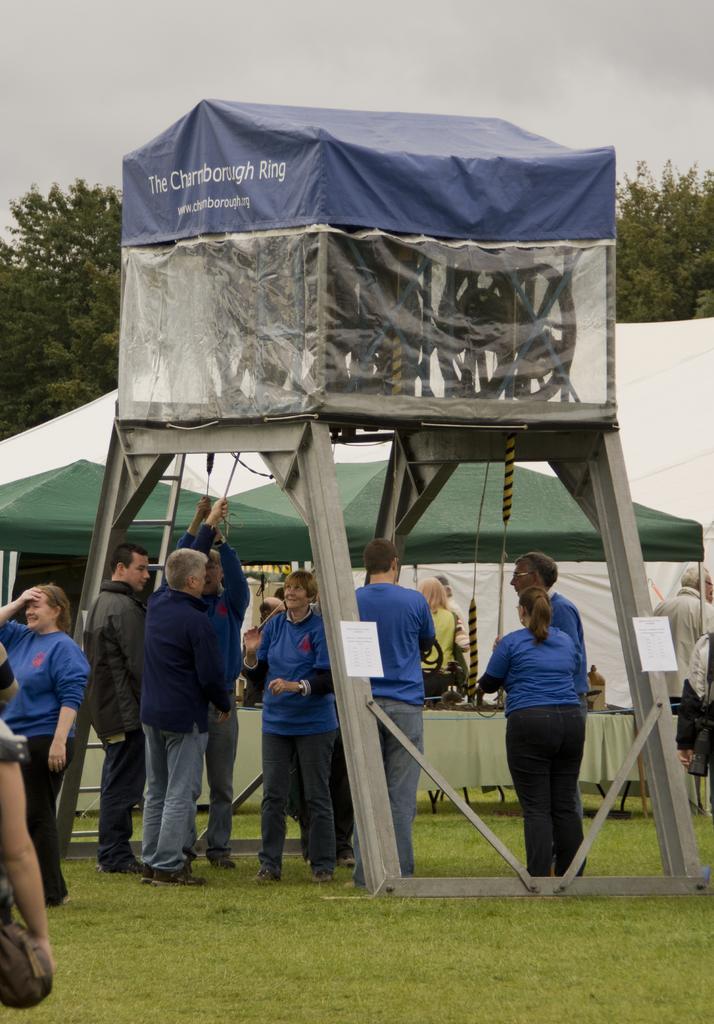Can you describe this image briefly? In this image, we can see people standing and there are tents and we can see trees. 